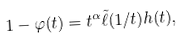Convert formula to latex. <formula><loc_0><loc_0><loc_500><loc_500>1 - \varphi ( t ) = t ^ { \alpha } \tilde { \ell } ( 1 / t ) h ( t ) ,</formula> 